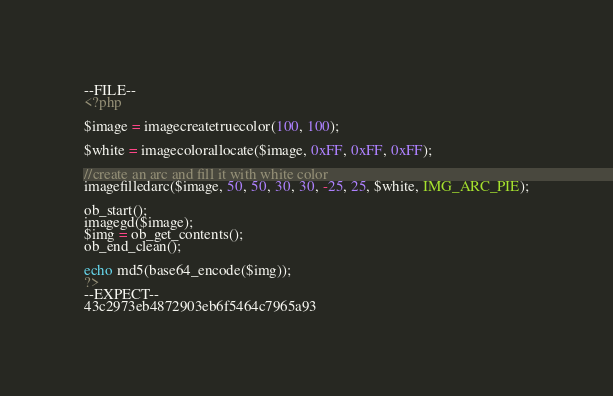<code> <loc_0><loc_0><loc_500><loc_500><_PHP_>--FILE--
<?php

$image = imagecreatetruecolor(100, 100);

$white = imagecolorallocate($image, 0xFF, 0xFF, 0xFF);

//create an arc and fill it with white color    
imagefilledarc($image, 50, 50, 30, 30, -25, 25, $white, IMG_ARC_PIE);

ob_start();
imagegd($image);
$img = ob_get_contents();
ob_end_clean();

echo md5(base64_encode($img));
?>
--EXPECT--
43c2973eb4872903eb6f5464c7965a93
</code> 